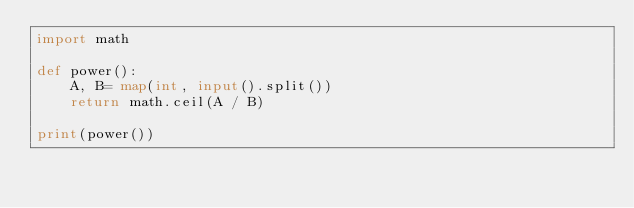<code> <loc_0><loc_0><loc_500><loc_500><_Python_>import math

def power():
    A, B= map(int, input().split())
    return math.ceil(A / B)

print(power())</code> 